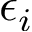Convert formula to latex. <formula><loc_0><loc_0><loc_500><loc_500>\epsilon _ { i }</formula> 